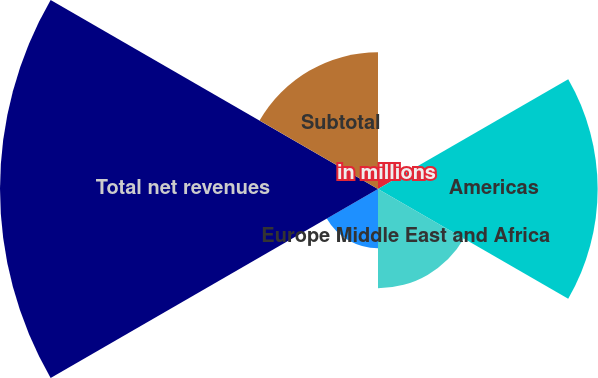<chart> <loc_0><loc_0><loc_500><loc_500><pie_chart><fcel>in millions<fcel>Americas<fcel>Europe Middle East and Africa<fcel>Asia<fcel>Total net revenues<fcel>Subtotal<nl><fcel>2.41%<fcel>24.01%<fcel>10.84%<fcel>6.47%<fcel>41.32%<fcel>14.95%<nl></chart> 